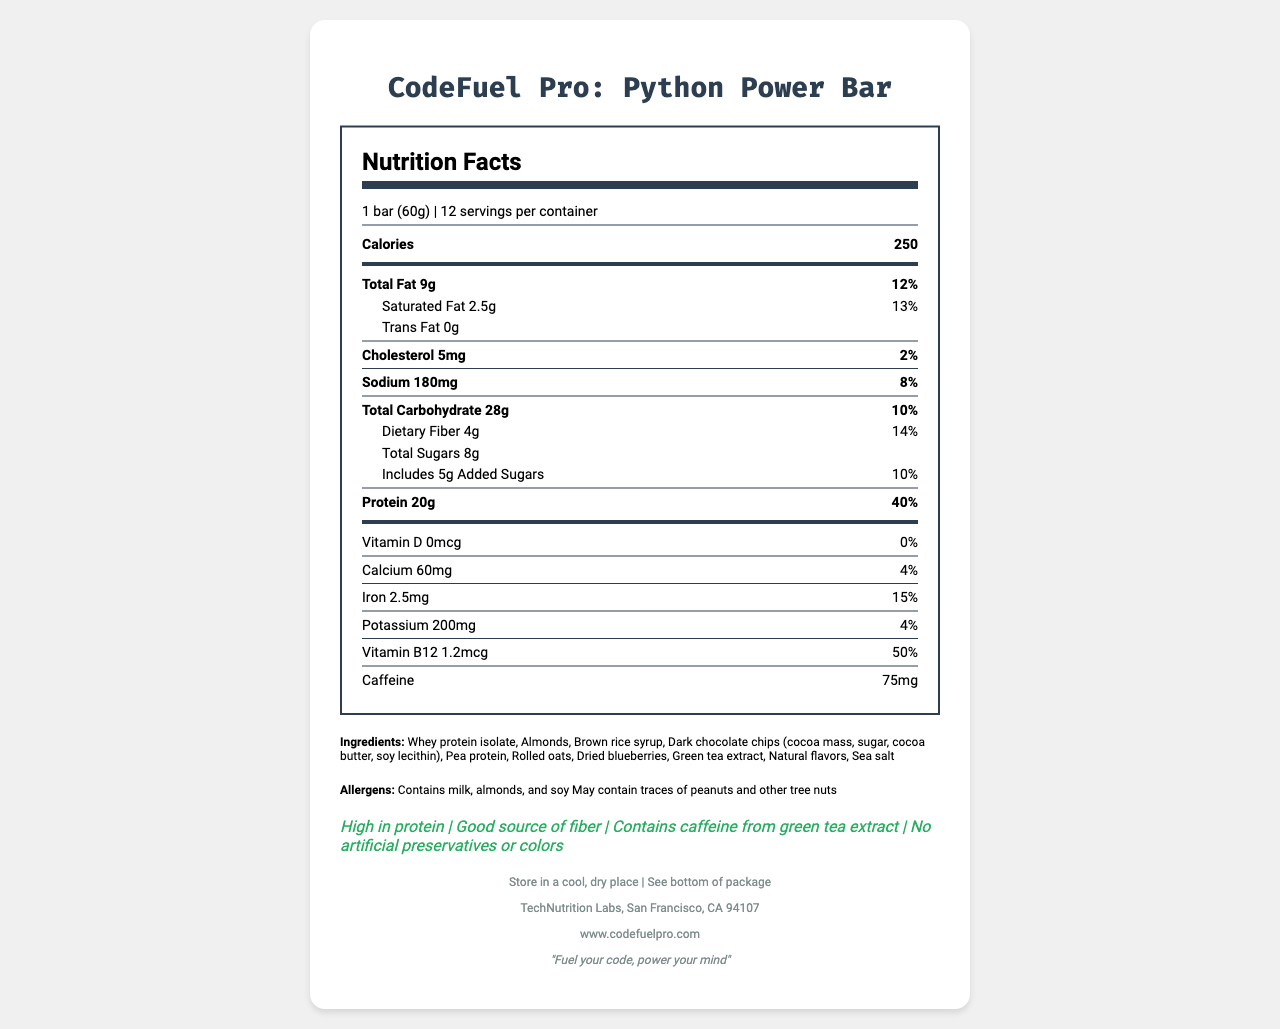what is the product name? The document mentions the product name at the top of the Nutrition Facts Label.
Answer: CodeFuel Pro: Python Power Bar how many calories are in one serving? The calories per serving are listed directly under the serving size on the nutrition label.
Answer: 250 calories what is the serving size? The serving size is mentioned right below the product name and above the calories information.
Answer: 1 bar (60g) which ingredient is listed first? The ingredients list starts with "Whey protein isolate" indicating it's the first ingredient.
Answer: Whey protein isolate how many grams of protein are in each serving? The protein content per serving is listed on the nutrition label under the macronutrient section.
Answer: 20g how much caffeine is in the product? The amount of caffeine is listed towards the bottom of the nutrition label.
Answer: 75mg how much iron does one serving provide? This information can be found in the section listing vitamins and minerals.
Answer: 2.5mg how many servings are in the container? A. 10 B. 12 C. 14 D. 16 The servings per container are listed next to the serving size information.
Answer: B. 12 which of the following claims is true about the snack bar? I. Contains caffeine from green tea extract II. High in trans fat III. Good source of vitamin D A. I only B. I and III only C. I and II only D. All of the above The label states that the product contains caffeine from green tea extract. It does not mention high trans fat or being a good source of vitamin D.
Answer: A. I only does this product contain any nuts? The allergy information mentions that the product contains almonds and may contain traces of other tree nuts.
Answer: Yes what company manufactures this product? The manufacturer's information is located at the bottom of the document.
Answer: TechNutrition Labs, San Francisco, CA 94107 describe the main idea of this Nutrition Facts Label. The label is designed to inform consumers about what they are consuming in each serving of the product, any dietary and allergic information, and other key facts.
Answer: This document provides detailed nutritional information about the CodeFuel Pro: Python Power Bar. It lists the serving size, calorie count, macronutrients, and micronutrients, as well as the ingredients and any potential allergens. Additionally, it includes health claims about the product and the manufacturer's contact information. what is the source of caffeine in the product? The document specifies that caffeine is derived from green tea extract in the claims section.
Answer: Green tea extract how much vitamin B12 is included per serving? The vitamin content, including vitamin B12, is listed in the vitamins and minerals section of the nutrition label.
Answer: 1.2mcg are there any artificial preservatives or colors in this product? One of the claims mentioned is "No artificial preservatives or colors."
Answer: No what is the fiber content per serving? The dietary fiber content is listed under the total carbohydrates section.
Answer: 4g what is the daily value percentage of saturated fat per serving? The daily value percentage for saturated fat is provided next to the saturated fat amount.
Answer: 13% cannot the best before date be found in the rendered document? The document mentions "See bottom of package" for the best before date, which means it is not directly visible in the rendered document.
Answer: Not enough information 